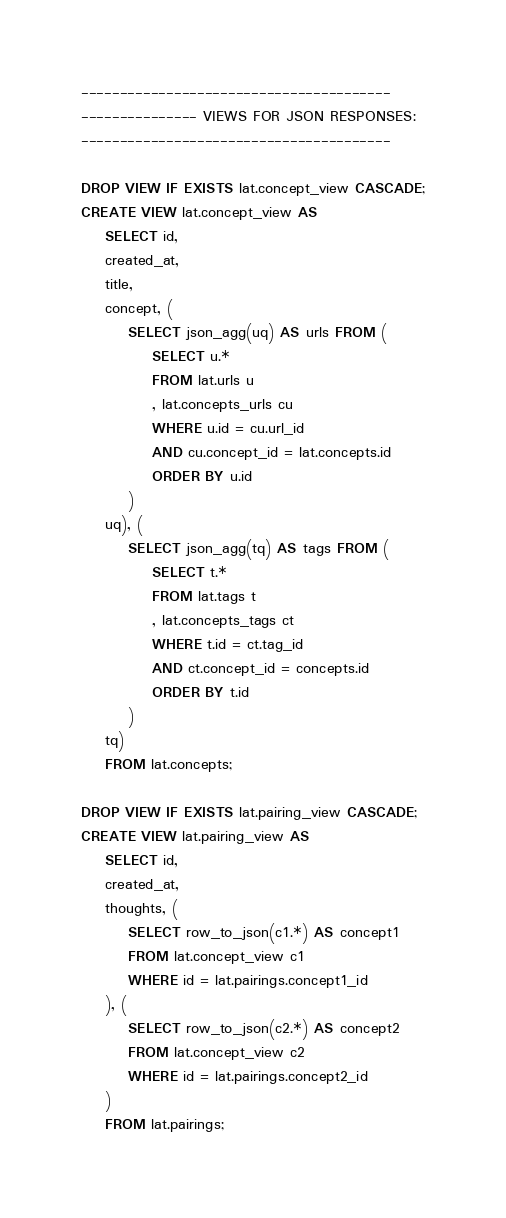Convert code to text. <code><loc_0><loc_0><loc_500><loc_500><_SQL_>----------------------------------------
--------------- VIEWS FOR JSON RESPONSES:
----------------------------------------

DROP VIEW IF EXISTS lat.concept_view CASCADE;
CREATE VIEW lat.concept_view AS
	SELECT id,
	created_at,
	title,
	concept, (
		SELECT json_agg(uq) AS urls FROM (
			SELECT u.*
			FROM lat.urls u
			, lat.concepts_urls cu
			WHERE u.id = cu.url_id
			AND cu.concept_id = lat.concepts.id
			ORDER BY u.id
		)
	uq), (
		SELECT json_agg(tq) AS tags FROM (
			SELECT t.*
			FROM lat.tags t
			, lat.concepts_tags ct
			WHERE t.id = ct.tag_id
			AND ct.concept_id = concepts.id
			ORDER BY t.id
		)
	tq)
	FROM lat.concepts;

DROP VIEW IF EXISTS lat.pairing_view CASCADE;
CREATE VIEW lat.pairing_view AS
	SELECT id,
	created_at,
	thoughts, (
		SELECT row_to_json(c1.*) AS concept1
		FROM lat.concept_view c1
		WHERE id = lat.pairings.concept1_id
	), (
		SELECT row_to_json(c2.*) AS concept2
		FROM lat.concept_view c2
		WHERE id = lat.pairings.concept2_id
	)
	FROM lat.pairings;

</code> 